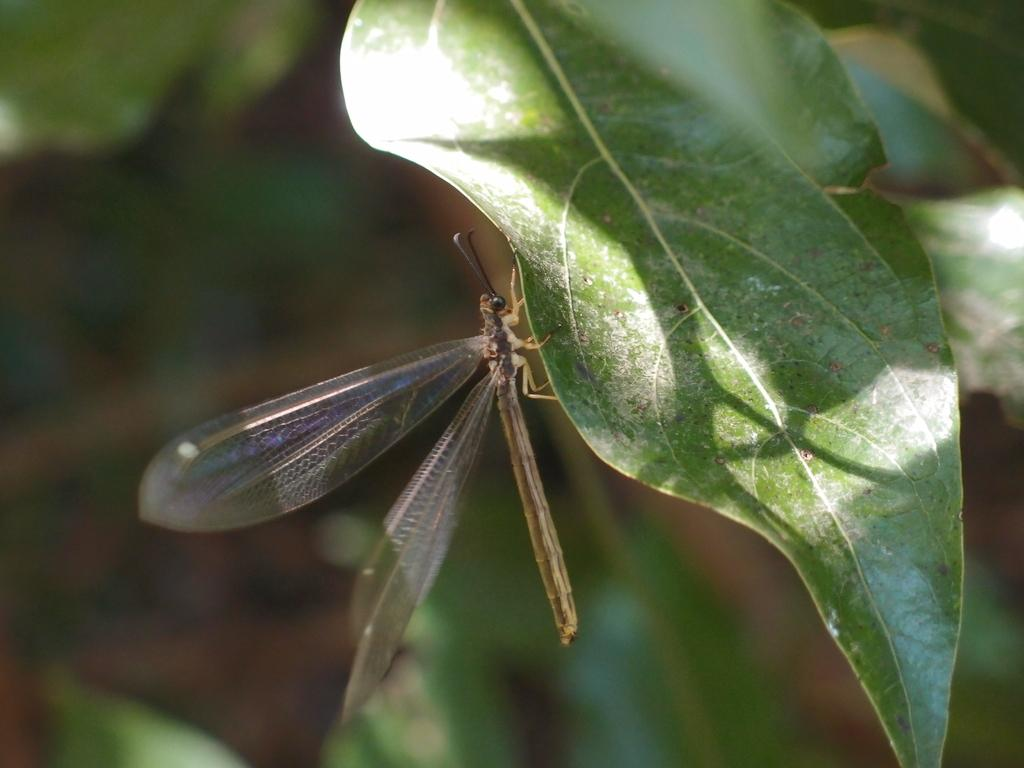What type of insect is present in the image? There is a dragonfly in the image. What other object can be seen in the image? There is a leaf in the image. Can you describe the background of the image? The background of the image is blurry. How many chairs are visible in the image? There are no chairs present in the image. What type of metal is the hose made of in the image? There is no hose present in the image. 